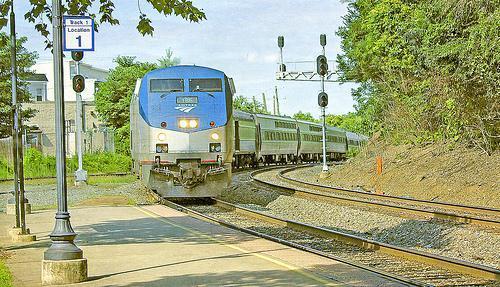How many sets of tracks are there?
Give a very brief answer. 2. 